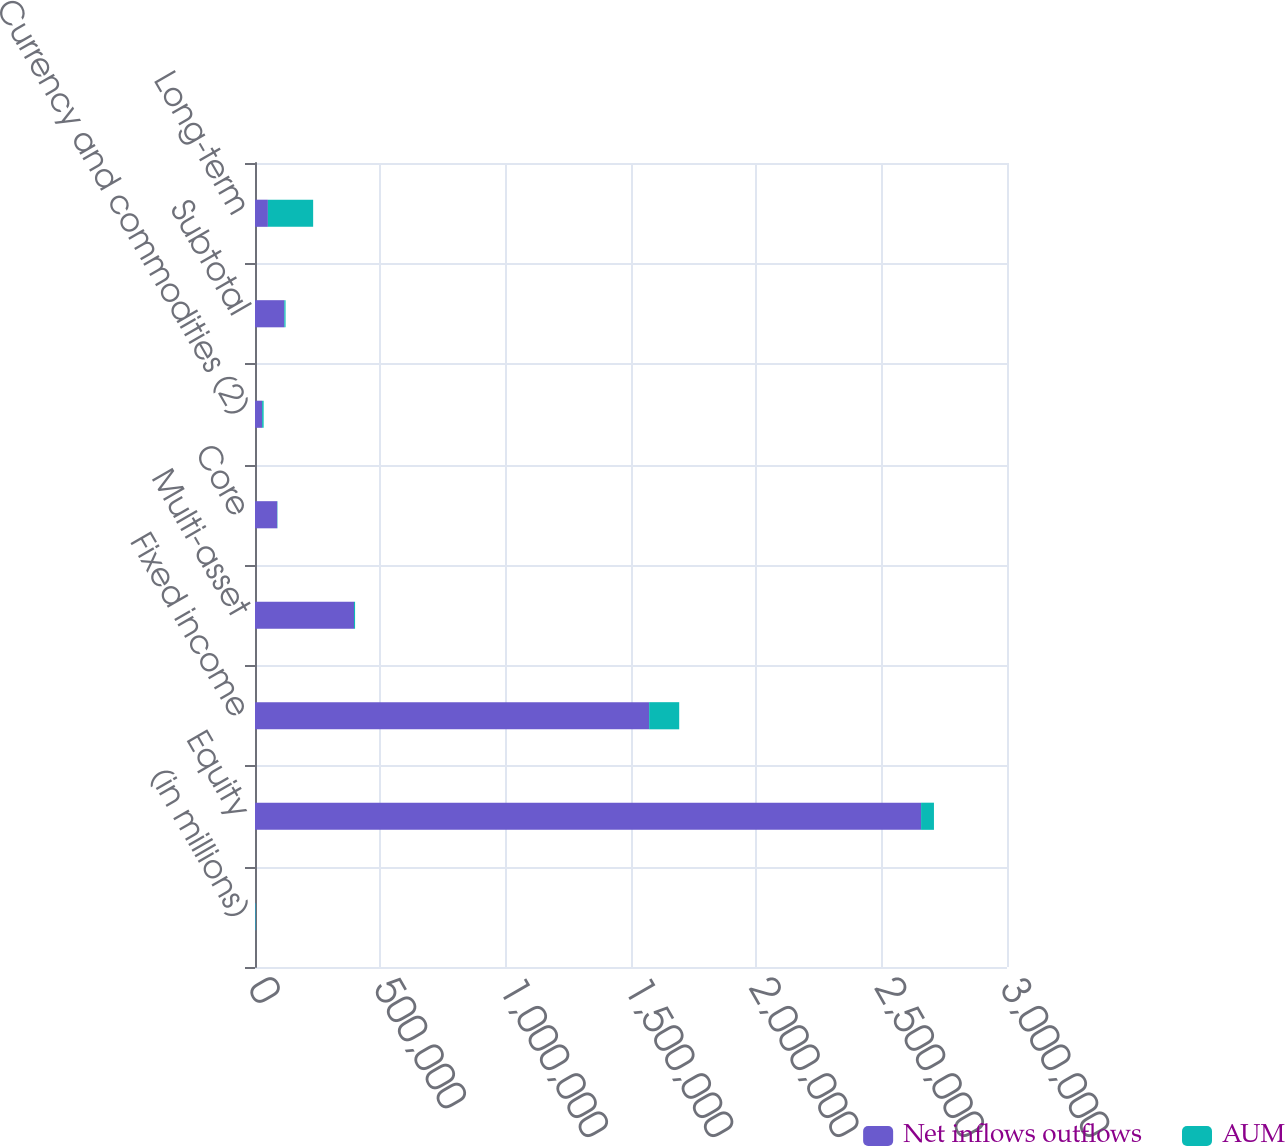<chart> <loc_0><loc_0><loc_500><loc_500><stacked_bar_chart><ecel><fcel>(in millions)<fcel>Equity<fcel>Fixed income<fcel>Multi-asset<fcel>Core<fcel>Currency and commodities (2)<fcel>Subtotal<fcel>Long-term<nl><fcel>Net inflows outflows<fcel>2016<fcel>2.65718e+06<fcel>1.57236e+06<fcel>395007<fcel>88630<fcel>28308<fcel>116938<fcel>51424<nl><fcel>AUM<fcel>2016<fcel>51424<fcel>119955<fcel>4227<fcel>1165<fcel>6123<fcel>4958<fcel>180564<nl></chart> 